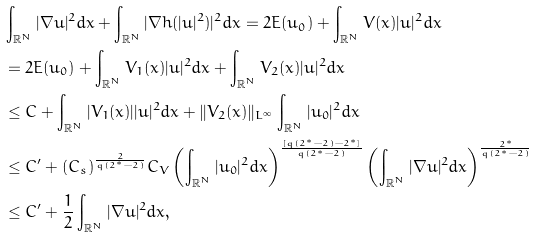<formula> <loc_0><loc_0><loc_500><loc_500>& \int _ { \mathbb { R } ^ { N } } | \nabla u | ^ { 2 } d x + \int _ { \mathbb { R } ^ { N } } | \nabla h ( | u | ^ { 2 } ) | ^ { 2 } d x = 2 E ( u _ { 0 } ) + \int _ { \mathbb { R } ^ { N } } V ( x ) | u | ^ { 2 } d x \\ & = 2 E ( u _ { 0 } ) + \int _ { \mathbb { R } ^ { N } } V _ { 1 } ( x ) | u | ^ { 2 } d x + \int _ { \mathbb { R } ^ { N } } V _ { 2 } ( x ) | u | ^ { 2 } d x \\ & \leq C + \int _ { \mathbb { R } ^ { N } } | V _ { 1 } ( x ) | | u | ^ { 2 } d x + \| V _ { 2 } ( x ) \| _ { L ^ { \infty } } \int _ { \mathbb { R } ^ { N } } | u _ { 0 } | ^ { 2 } d x \\ & \leq C ^ { \prime } + ( C _ { s } ) ^ { \frac { 2 } { q ( 2 ^ { * } - 2 ) } } C _ { V } \left ( \int _ { \mathbb { R } ^ { N } } | u _ { 0 } | ^ { 2 } d x \right ) ^ { \frac { [ q ( 2 ^ { * } - 2 ) - 2 ^ { * } ] } { q ( 2 ^ { * } - 2 ) } } \left ( \int _ { \mathbb { R } ^ { N } } | \nabla u | ^ { 2 } d x \right ) ^ { \frac { 2 ^ { * } } { q ( 2 ^ { * } - 2 ) } } \\ & \leq C ^ { \prime } + \frac { 1 } { 2 } \int _ { \mathbb { R } ^ { N } } | \nabla u | ^ { 2 } d x ,</formula> 